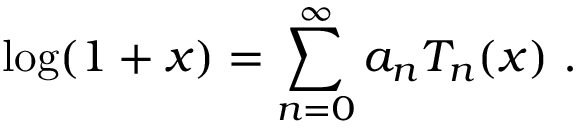Convert formula to latex. <formula><loc_0><loc_0><loc_500><loc_500>\log ( 1 + x ) = \sum _ { n = 0 } ^ { \infty } a _ { n } T _ { n } ( x ) .</formula> 